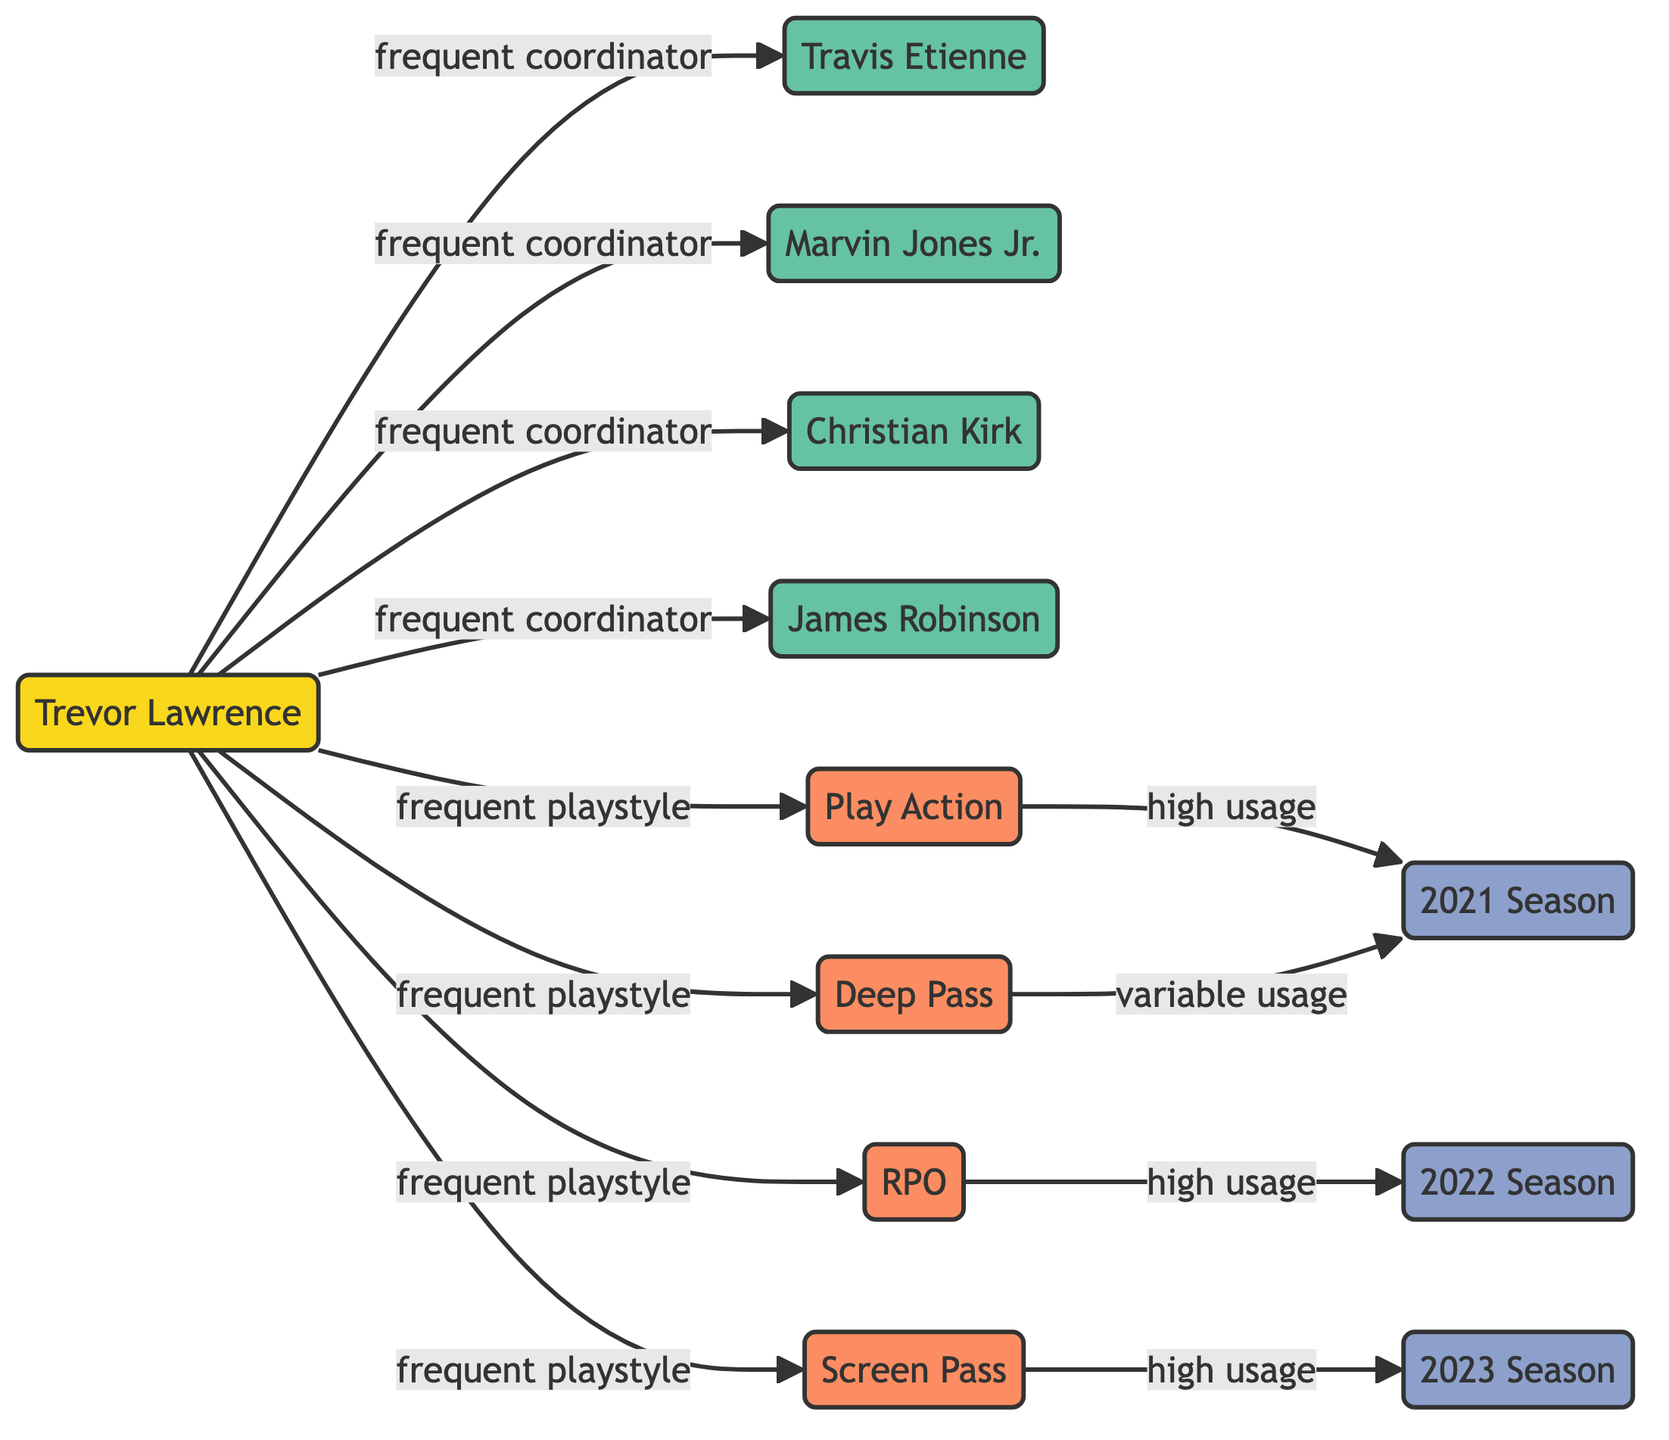What are the key teammates connected to Trevor Lawrence? The diagram shows multiple connections from Trevor Lawrence to teammates including Travis Etienne, Marvin Jones Jr., Christian Kirk, and James Robinson. Each connection is labeled as a "frequent coordinator," indicating they frequently collaborate on plays.
Answer: Travis Etienne, Marvin Jones Jr., Christian Kirk, James Robinson How many play styles are highlighted in the diagram? The diagram lists four distinct play styles connected to Trevor Lawrence: Play Action, RPO (Run-Pass Option), Screen Pass, and Deep Pass. Therefore, the total number of play styles is counted based on these unique nodes.
Answer: 4 Which play style had high usage in the 2021 season? The diagram indicates that the Play Action style is connected to the 2021 Season with a label of "high usage." This means that among the styles listed, Play Action was specifically marked for frequent use during that season.
Answer: Play Action What is the relationship between Trevor Lawrence and the Deep Pass play style? The diagram displays a connection from Trevor Lawrence to the Deep Pass play style labeled as "frequent playstyle," and another connection to the 2021 Season labeled as "variable usage." This indicates that while it is a frequent choice, its use was inconsistent in the particular season.
Answer: frequent playstyle In which season did the RPO play style have high usage? The diagram shows that the connection from RPO leads to the 2022 Season with a label indicating "high usage." Thus, the RPO was prominently utilized in that specific year.
Answer: 2022 Season Which play style had high usage in the 2023 season? The diagram indicates that the Screen Pass play style is connected to the 2023 Season with a label of "high usage." This means it was prominently featured in that season of play.
Answer: Screen Pass How many total connections are there from Trevor Lawrence to his teammates? The diagram points out four direct connections from Trevor Lawrence to his teammates, each representing a collaborator in game strategy. The total is counted by counting each direct connection displayed.
Answer: 4 What do the dashed lines represent between Play Action and the 2021 Season? The line from Play Action to the 2021 Season is labeled "high usage," indicating a strong relationship where the Play Action style was frequently employed during that specific season. This is indicated by the prominent connection and label.
Answer: high usage 